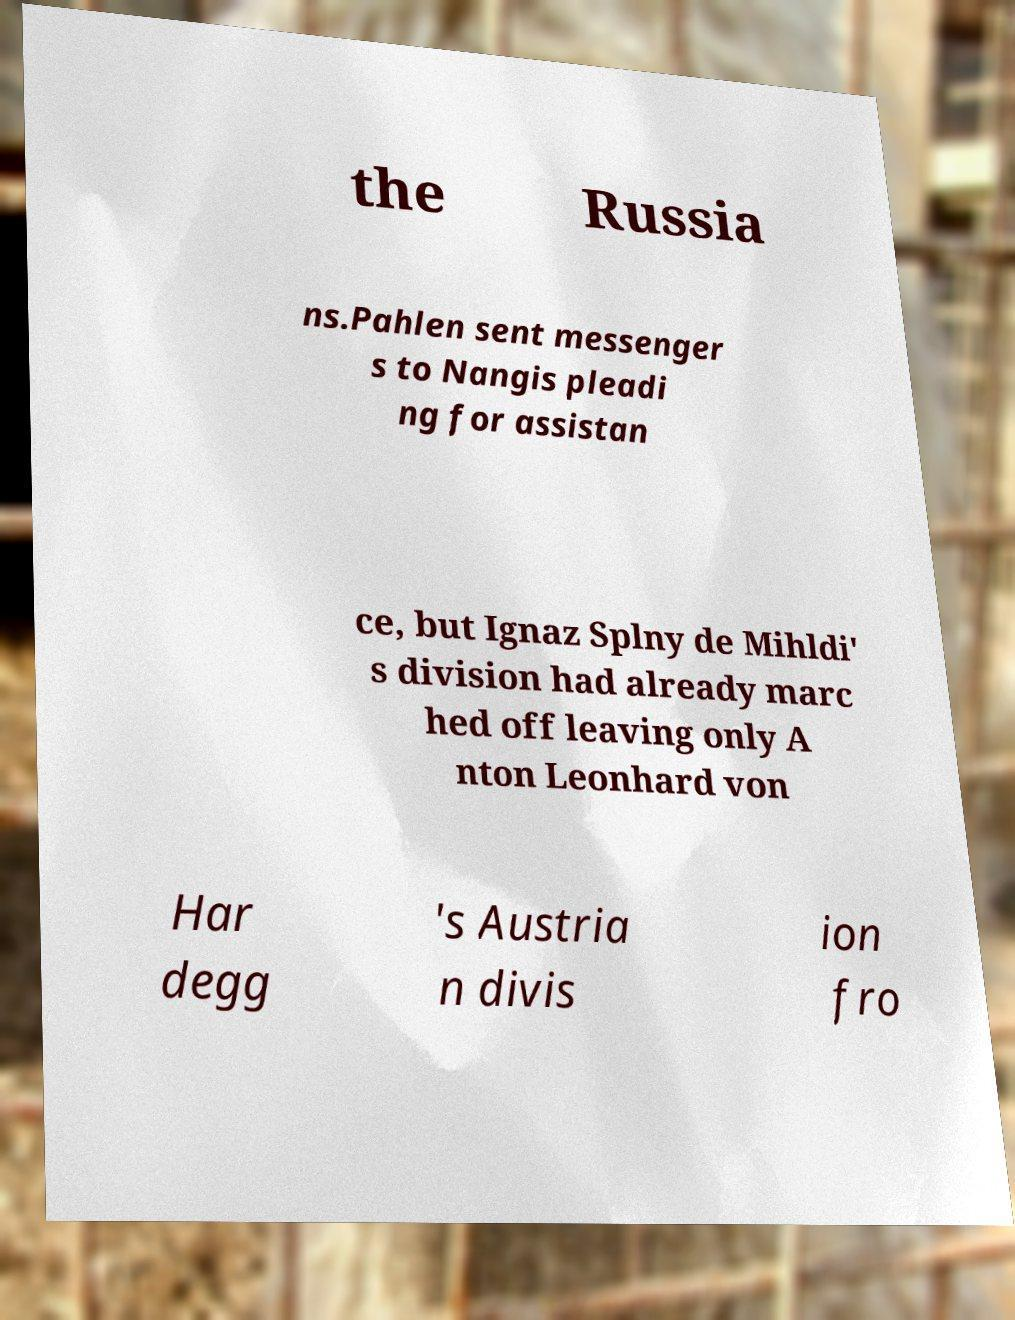Can you accurately transcribe the text from the provided image for me? the Russia ns.Pahlen sent messenger s to Nangis pleadi ng for assistan ce, but Ignaz Splny de Mihldi' s division had already marc hed off leaving only A nton Leonhard von Har degg 's Austria n divis ion fro 